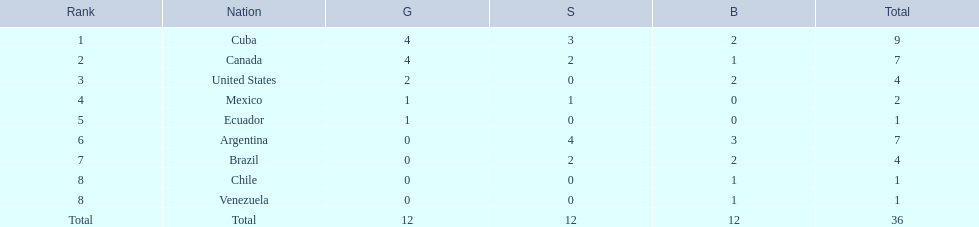What were the amounts of bronze medals won by the countries? 2, 1, 2, 0, 0, 3, 2, 1, 1. Which is the highest? 3. Which nation had this amount? Argentina. 